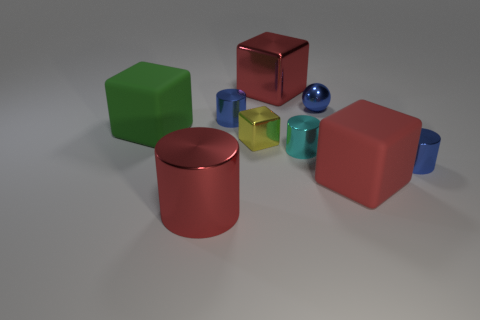What objects besides the blocks are in the image, and how do they compare in size? In addition to the blocks, there are spherical objects, such as a small blue sphere and a slightly larger, shiny, blue-green sphere. These spheres are smaller in scale when compared to the larger blocks but are larger than the smallest cubes. 